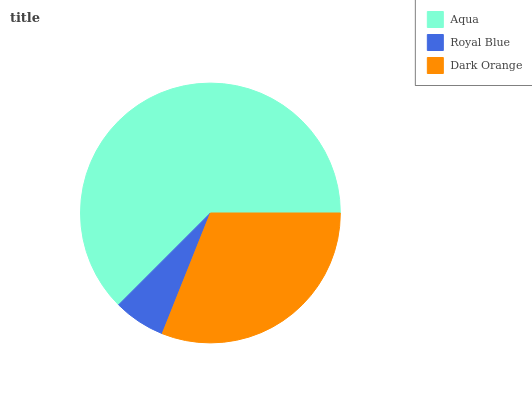Is Royal Blue the minimum?
Answer yes or no. Yes. Is Aqua the maximum?
Answer yes or no. Yes. Is Dark Orange the minimum?
Answer yes or no. No. Is Dark Orange the maximum?
Answer yes or no. No. Is Dark Orange greater than Royal Blue?
Answer yes or no. Yes. Is Royal Blue less than Dark Orange?
Answer yes or no. Yes. Is Royal Blue greater than Dark Orange?
Answer yes or no. No. Is Dark Orange less than Royal Blue?
Answer yes or no. No. Is Dark Orange the high median?
Answer yes or no. Yes. Is Dark Orange the low median?
Answer yes or no. Yes. Is Royal Blue the high median?
Answer yes or no. No. Is Royal Blue the low median?
Answer yes or no. No. 